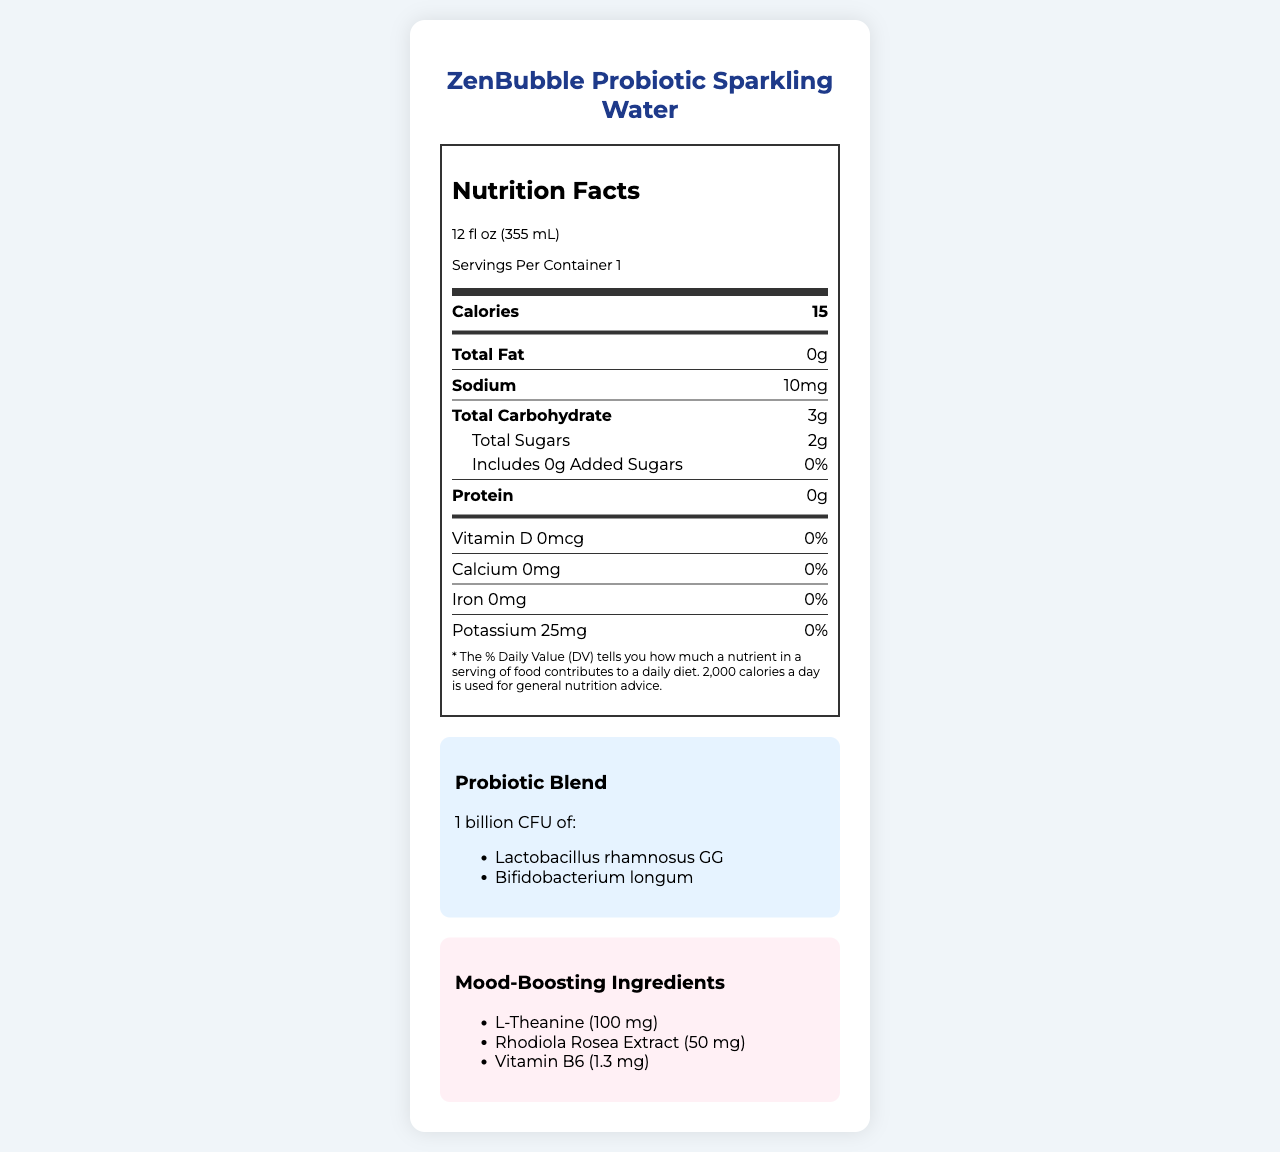what is the product name? The product name is listed at the top of the document.
Answer: ZenBubble Probiotic Sparkling Water what is the serving size? The serving size is specified just below the product name in the document.
Answer: 12 fl oz (355 mL) how many calories are in one serving? The number of calories per serving is listed in the nutrition label section under "Calories".
Answer: 15 what is the sodium content per serving? The sodium content per serving is listed in the nutrition label.
Answer: 10 mg how many grams of total sugars are in the product? The total sugars are listed under the "Total Carbohydrate" section of the nutrition label.
Answer: 2 g which probiotic strains are included in the blend? The probiotic strains are listed in the "Probiotic Blend" section of the document.
Answer: Lactobacillus rhamnosus GG and Bifidobacterium longum which mood-boosting ingredient has the highest amount? The amount of L-Theanine is 100 mg, which is higher than the other mood-boosting ingredients listed.
Answer: L-Theanine what percentage of the daily value of Vitamin B6 does the product provide? The daily value percentage for Vitamin B6 is provided next to its amount in the "Mood-Boosting Ingredients" section.
Answer: 76% what is the flavor profile of the product? The flavor profile is listed in the data description section.
Answer: Lavender Lemon is the packaging recyclable? yes/no The document states that the packaging is recyclable aluminum can.
Answer: Yes does the product contain any added sugars? yes/no The nutrition label specifies that there are 0 grams of added sugars.
Answer: No what are the key marketing angles of the product? These marketing angles are listed in the "Marketing Angles" section of the document.
Answer: Gut health meets mental wellness, Instagrammable minimalist design, Zero artificial ingredients, Sustainably sourced ingredients who is the target audience for ZenBubble? The target audience is described in the data section under "Target Audience".
Answer: Health-conscious millennials and Gen Z consumers which of the following is not a marketing angle for ZenBubble? A. Gut health meets mental wellness B. High caffeine content C. Instagrammable minimalist design D. Zero artificial ingredients The options A, C, and D are listed as marketing angles, but high caffeine content is not mentioned.
Answer: B how many mood-boosting ingredients are in ZenBubble? The document lists three mood-boosting ingredients: L-Theanine, Rhodiola Rosea Extract, and Vitamin B6.
Answer: 3 which hashtag is recommended for sharing ZenBubble on social media? A. #ZenBubble B. #BeverageBliss C. #WellnessDrink D. #CleanBeverage #ZenBubble is one of the suggested hashtags listed in the document.
Answer: A what is the purpose of the probiotic blend in the product? The probiotic blend is included to support gut health, which is mentioned in the key marketing angles.
Answer: Support gut health which vitamin and mineral have 0% daily value in the product? The nutrition label indicates 0% daily value for Vitamin D, Calcium, and Iron.
Answer: Vitamin D, Calcium, Iron what is the main idea of the document? The document covers multiple aspects of the product to inform consumers about its benefits and features, with emphasis on its health benefits and sustainable branding.
Answer: The document provides detailed information about the ZenBubble Probiotic Sparkling Water, including its nutrition facts, probiotics, mood-boosting ingredients, flavor profile, packaging, brand story, target audience, and marketing angles. what is the exact amount of Bifidobacterium longum in the product? The document only provides the total amount of the probiotic blend as 1 billion CFU but does not give specific amounts for each strain.
Answer: Cannot be determined 